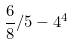Convert formula to latex. <formula><loc_0><loc_0><loc_500><loc_500>\frac { 6 } { 8 } / 5 - 4 ^ { 4 }</formula> 